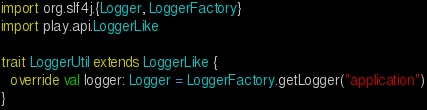Convert code to text. <code><loc_0><loc_0><loc_500><loc_500><_Scala_>import org.slf4j.{Logger, LoggerFactory}
import play.api.LoggerLike

trait LoggerUtil extends LoggerLike {
  override val logger: Logger = LoggerFactory.getLogger("application")
}
</code> 